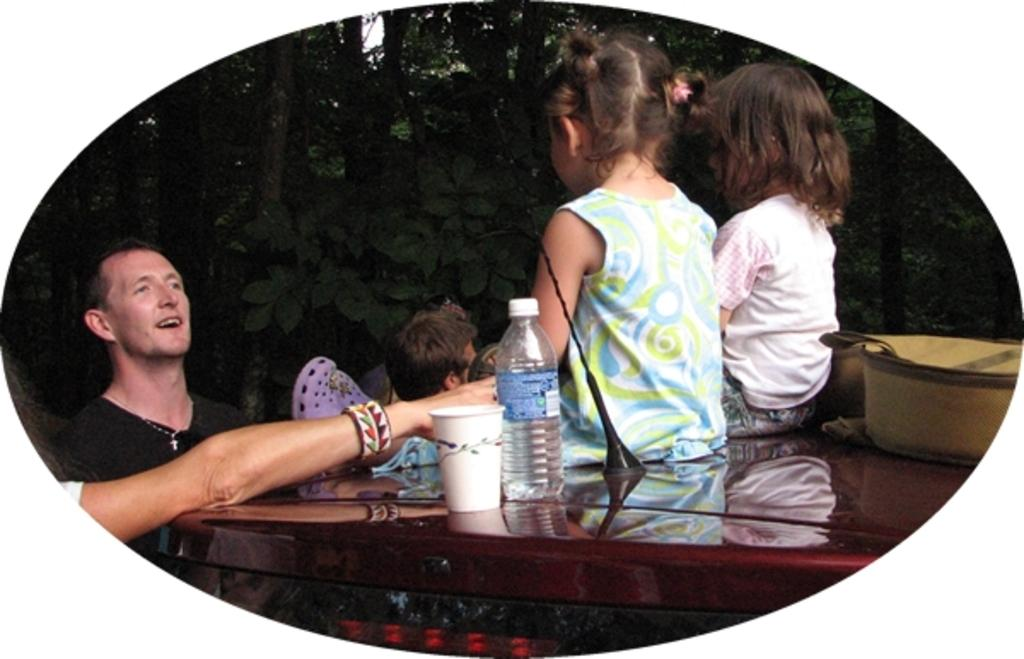What are the kids doing in the image? The two kids are sitting on a table. What else is on the table besides the kids? There is a bag, a bottle, and a cup on the table. What is the man in the image doing? There is a man standing in the image. What can be seen in the background of the image? Trees are visible in the background. What type of dress is the man wearing in the image? The man is not wearing a dress in the image; he is standing. 